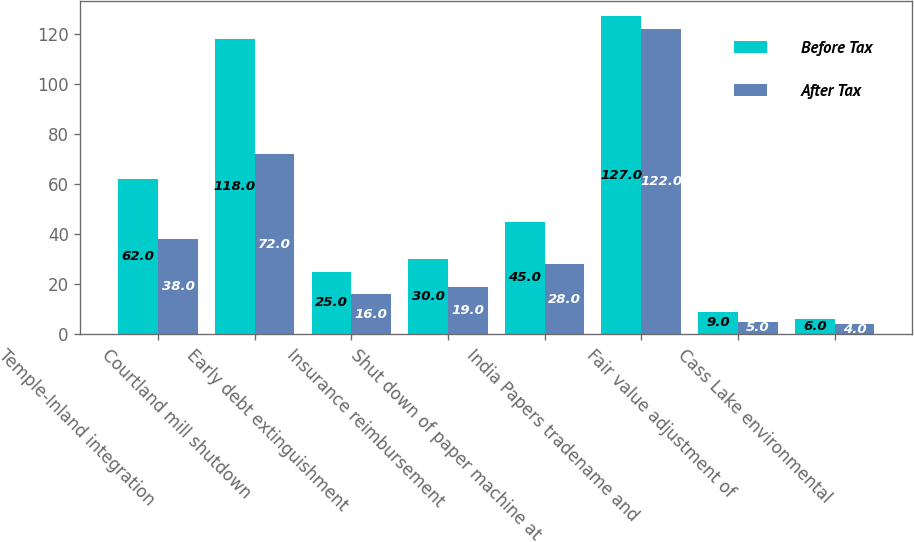Convert chart. <chart><loc_0><loc_0><loc_500><loc_500><stacked_bar_chart><ecel><fcel>Temple-Inland integration<fcel>Courtland mill shutdown<fcel>Early debt extinguishment<fcel>Insurance reimbursement<fcel>Shut down of paper machine at<fcel>India Papers tradename and<fcel>Fair value adjustment of<fcel>Cass Lake environmental<nl><fcel>Before Tax<fcel>62<fcel>118<fcel>25<fcel>30<fcel>45<fcel>127<fcel>9<fcel>6<nl><fcel>After Tax<fcel>38<fcel>72<fcel>16<fcel>19<fcel>28<fcel>122<fcel>5<fcel>4<nl></chart> 